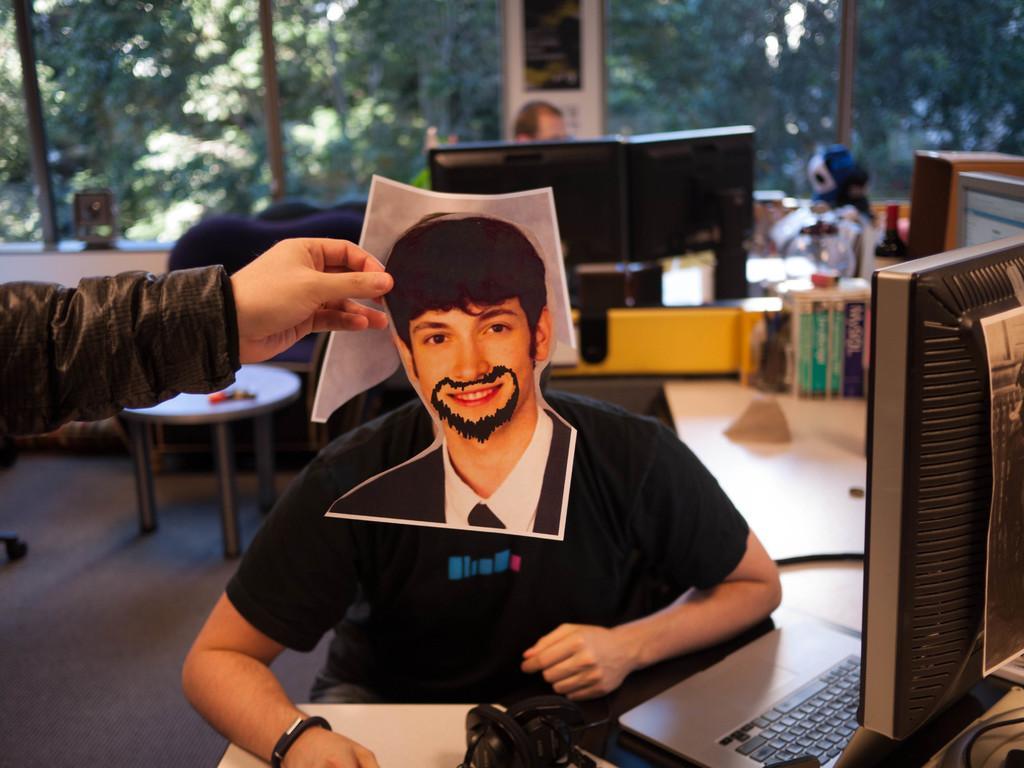Please provide a concise description of this image. In the image there is a man sitting on a chair. Bottom left side of the image there is a hand, He is holding a photo. Bottom right side of the image there is a screen and laptop. Top side of the image there is a glass window. Through the glass window we can see some trees. In the middle of the image there is a table on the table there are some products. 